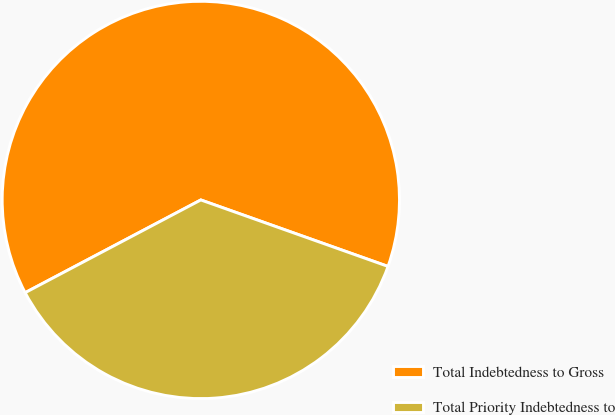Convert chart. <chart><loc_0><loc_0><loc_500><loc_500><pie_chart><fcel>Total Indebtedness to Gross<fcel>Total Priority Indebtedness to<nl><fcel>63.16%<fcel>36.84%<nl></chart> 